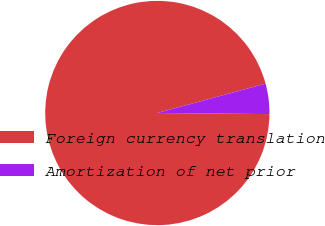<chart> <loc_0><loc_0><loc_500><loc_500><pie_chart><fcel>Foreign currency translation<fcel>Amortization of net prior<nl><fcel>95.63%<fcel>4.37%<nl></chart> 